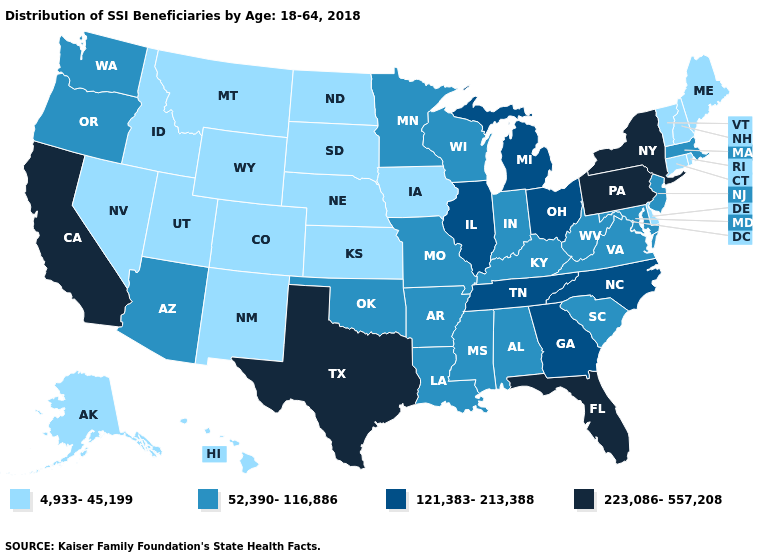Name the states that have a value in the range 223,086-557,208?
Short answer required. California, Florida, New York, Pennsylvania, Texas. Which states hav the highest value in the South?
Answer briefly. Florida, Texas. What is the value of New York?
Give a very brief answer. 223,086-557,208. What is the value of Alaska?
Quick response, please. 4,933-45,199. Which states have the lowest value in the USA?
Give a very brief answer. Alaska, Colorado, Connecticut, Delaware, Hawaii, Idaho, Iowa, Kansas, Maine, Montana, Nebraska, Nevada, New Hampshire, New Mexico, North Dakota, Rhode Island, South Dakota, Utah, Vermont, Wyoming. Does Illinois have a lower value than Pennsylvania?
Answer briefly. Yes. Is the legend a continuous bar?
Answer briefly. No. What is the value of Wisconsin?
Give a very brief answer. 52,390-116,886. What is the highest value in the USA?
Quick response, please. 223,086-557,208. Which states have the lowest value in the Northeast?
Be succinct. Connecticut, Maine, New Hampshire, Rhode Island, Vermont. Does Nebraska have the same value as Delaware?
Give a very brief answer. Yes. Among the states that border Virginia , does Maryland have the highest value?
Quick response, please. No. What is the value of Missouri?
Answer briefly. 52,390-116,886. Is the legend a continuous bar?
Give a very brief answer. No. Which states have the lowest value in the West?
Concise answer only. Alaska, Colorado, Hawaii, Idaho, Montana, Nevada, New Mexico, Utah, Wyoming. 